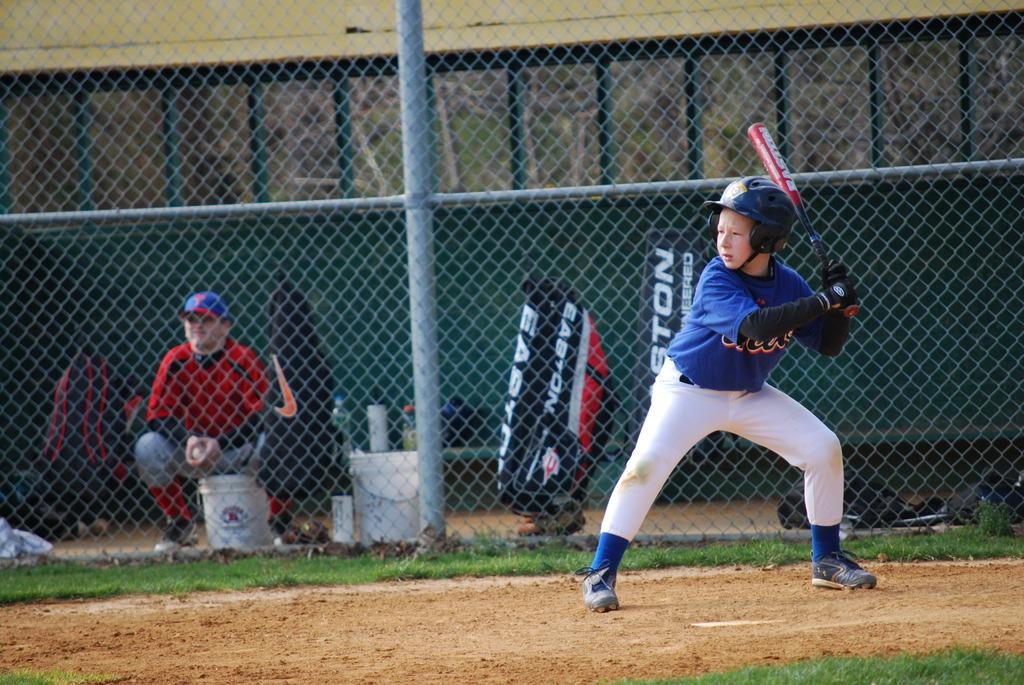<image>
Provide a brief description of the given image. a boy with the letters ton behind him 